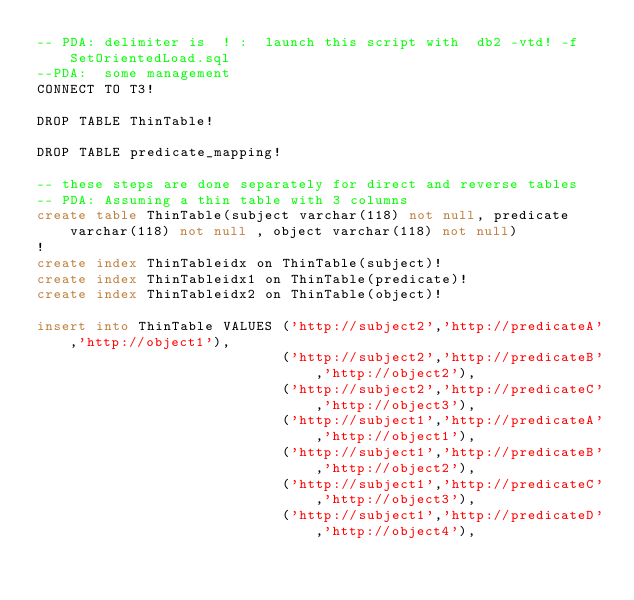Convert code to text. <code><loc_0><loc_0><loc_500><loc_500><_SQL_>-- PDA: delimiter is  ! :  launch this script with  db2 -vtd! -f SetOrientedLoad.sql
--PDA:  some management
CONNECT TO T3!

DROP TABLE ThinTable!

DROP TABLE predicate_mapping!

-- these steps are done separately for direct and reverse tables
-- PDA: Assuming a thin table with 3 columns
create table ThinTable(subject varchar(118) not null, predicate varchar(118) not null , object varchar(118) not null)
!
create index ThinTableidx on ThinTable(subject)!
create index ThinTableidx1 on ThinTable(predicate)!
create index ThinTableidx2 on ThinTable(object)!

insert into ThinTable VALUES ('http://subject2','http://predicateA','http://object1'),
                             ('http://subject2','http://predicateB','http://object2'),
                             ('http://subject2','http://predicateC','http://object3'),
                             ('http://subject1','http://predicateA','http://object1'),
                             ('http://subject1','http://predicateB','http://object2'),
                             ('http://subject1','http://predicateC','http://object3'),
                             ('http://subject1','http://predicateD','http://object4'),</code> 